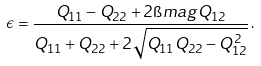<formula> <loc_0><loc_0><loc_500><loc_500>\epsilon = \frac { Q _ { 1 1 } - Q _ { 2 2 } + 2 \i m a g Q _ { 1 2 } } { Q _ { 1 1 } + Q _ { 2 2 } + 2 \sqrt { Q _ { 1 1 } Q _ { 2 2 } - Q _ { 1 2 } ^ { 2 } } } \, .</formula> 